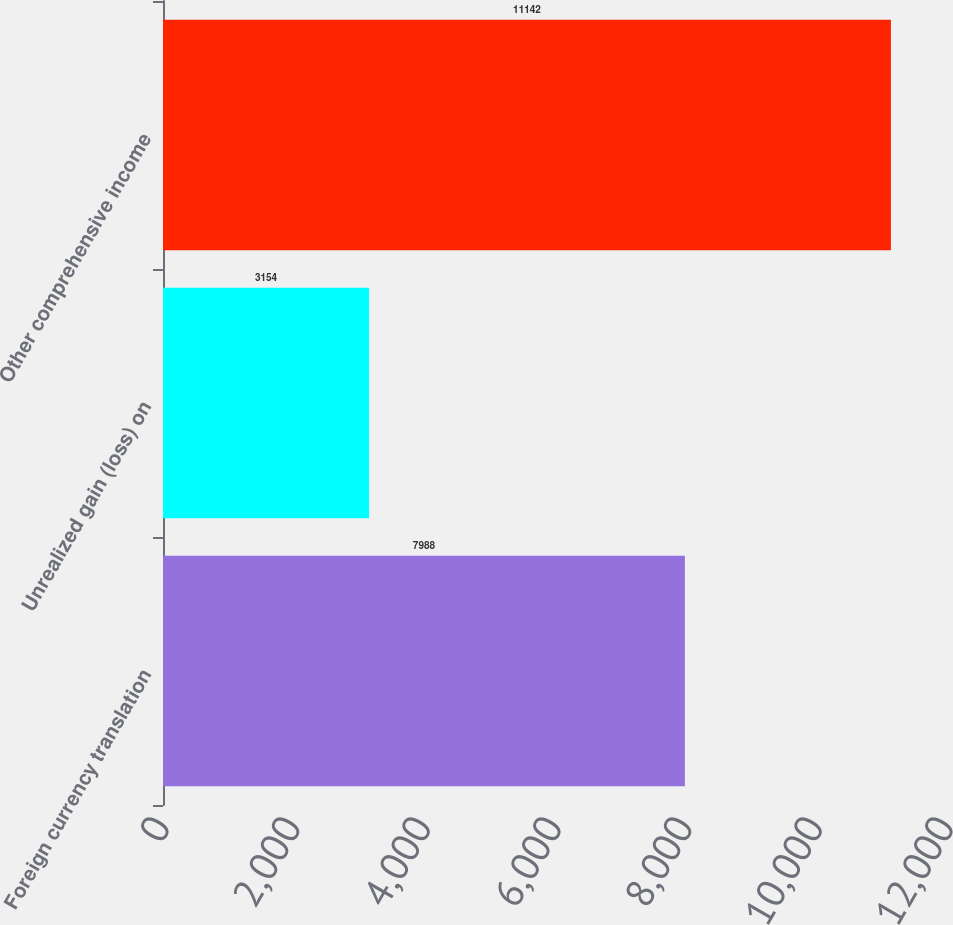<chart> <loc_0><loc_0><loc_500><loc_500><bar_chart><fcel>Foreign currency translation<fcel>Unrealized gain (loss) on<fcel>Other comprehensive income<nl><fcel>7988<fcel>3154<fcel>11142<nl></chart> 